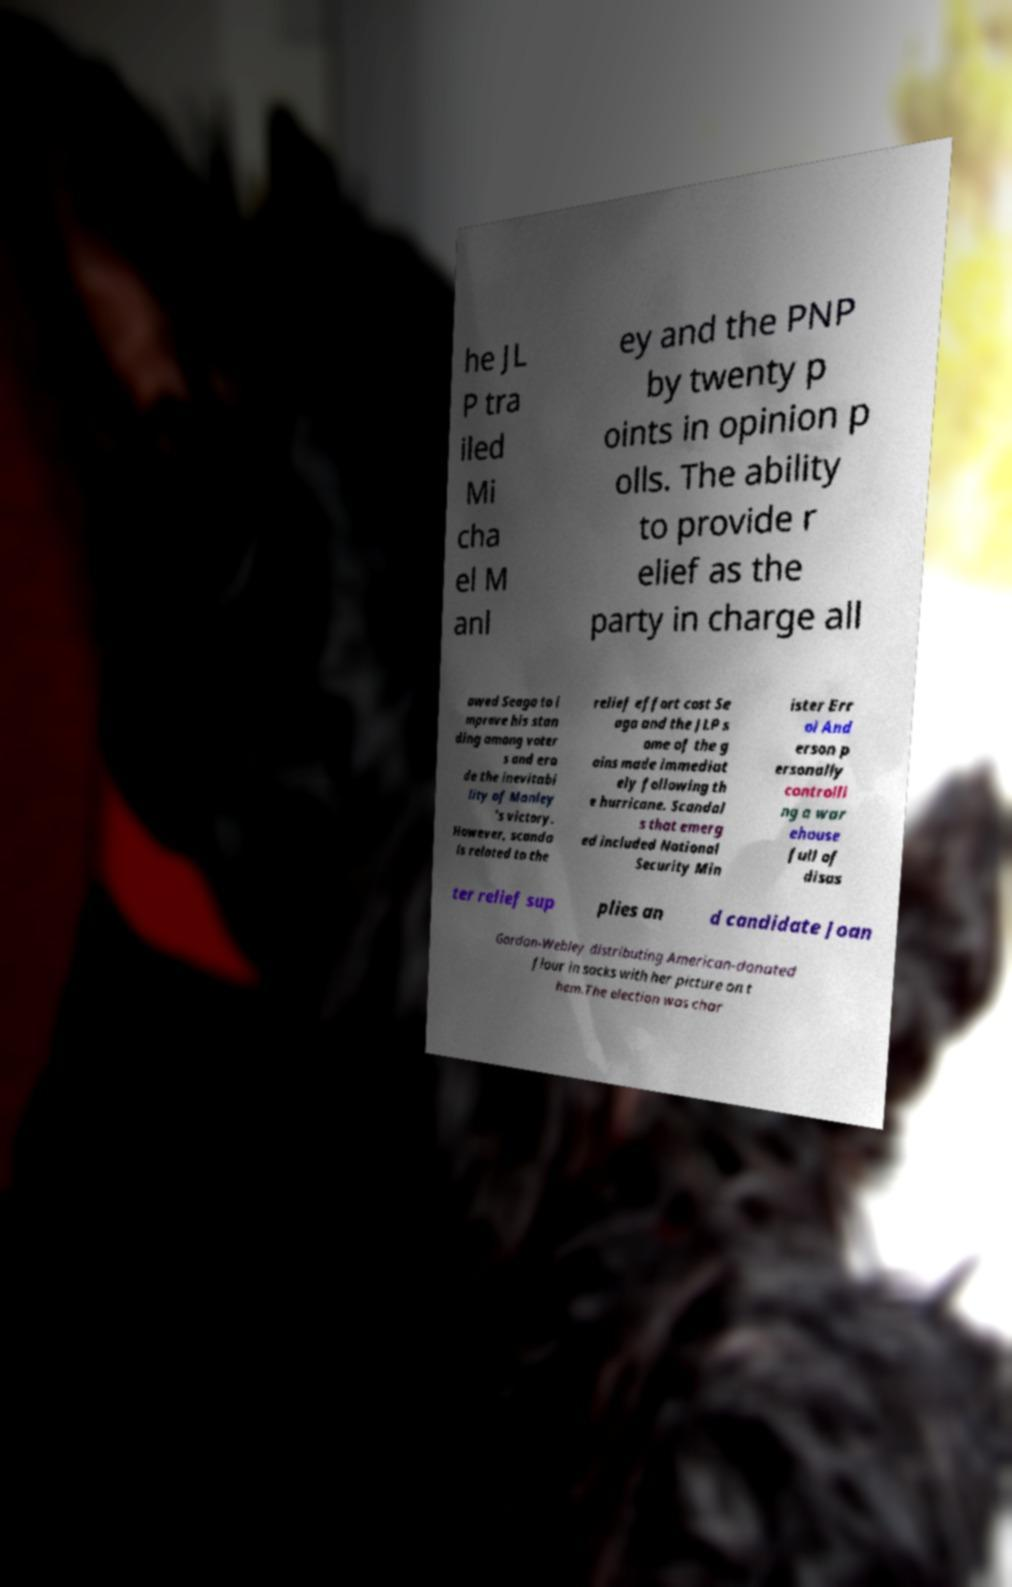Can you read and provide the text displayed in the image?This photo seems to have some interesting text. Can you extract and type it out for me? he JL P tra iled Mi cha el M anl ey and the PNP by twenty p oints in opinion p olls. The ability to provide r elief as the party in charge all owed Seaga to i mprove his stan ding among voter s and ero de the inevitabi lity of Manley 's victory. However, scanda ls related to the relief effort cost Se aga and the JLP s ome of the g ains made immediat ely following th e hurricane. Scandal s that emerg ed included National Security Min ister Err ol And erson p ersonally controlli ng a war ehouse full of disas ter relief sup plies an d candidate Joan Gordon-Webley distributing American-donated flour in sacks with her picture on t hem.The election was char 